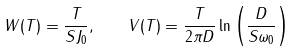<formula> <loc_0><loc_0><loc_500><loc_500>W ( T ) = \frac { T } { S J _ { 0 } } , \quad V ( T ) = \frac { T } { 2 \pi D } \ln \left ( \frac { D } { S \omega _ { 0 } } \right )</formula> 